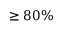Convert formula to latex. <formula><loc_0><loc_0><loc_500><loc_500>\geq 8 0 \%</formula> 